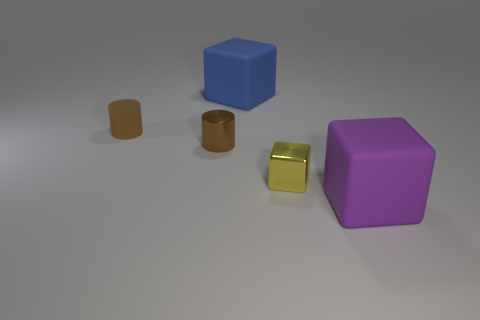What size is the rubber cube that is behind the large purple matte thing?
Provide a succinct answer. Large. Is there a tiny shiny thing of the same color as the small rubber cylinder?
Your response must be concise. Yes. Is the shiny cylinder the same color as the matte cylinder?
Provide a succinct answer. Yes. What shape is the tiny metal object that is the same color as the small matte object?
Your answer should be compact. Cylinder. There is a rubber block that is behind the small brown metal cylinder; how many metallic cubes are behind it?
Provide a short and direct response. 0. How many tiny cylinders are made of the same material as the yellow block?
Provide a short and direct response. 1. There is a large blue rubber block; are there any rubber cubes in front of it?
Ensure brevity in your answer.  Yes. What color is the matte thing that is the same size as the purple block?
Offer a terse response. Blue. What number of objects are either small things behind the tiny brown metal cylinder or large brown metallic things?
Your response must be concise. 1. There is a matte thing that is both in front of the blue object and behind the metal block; how big is it?
Your response must be concise. Small. 